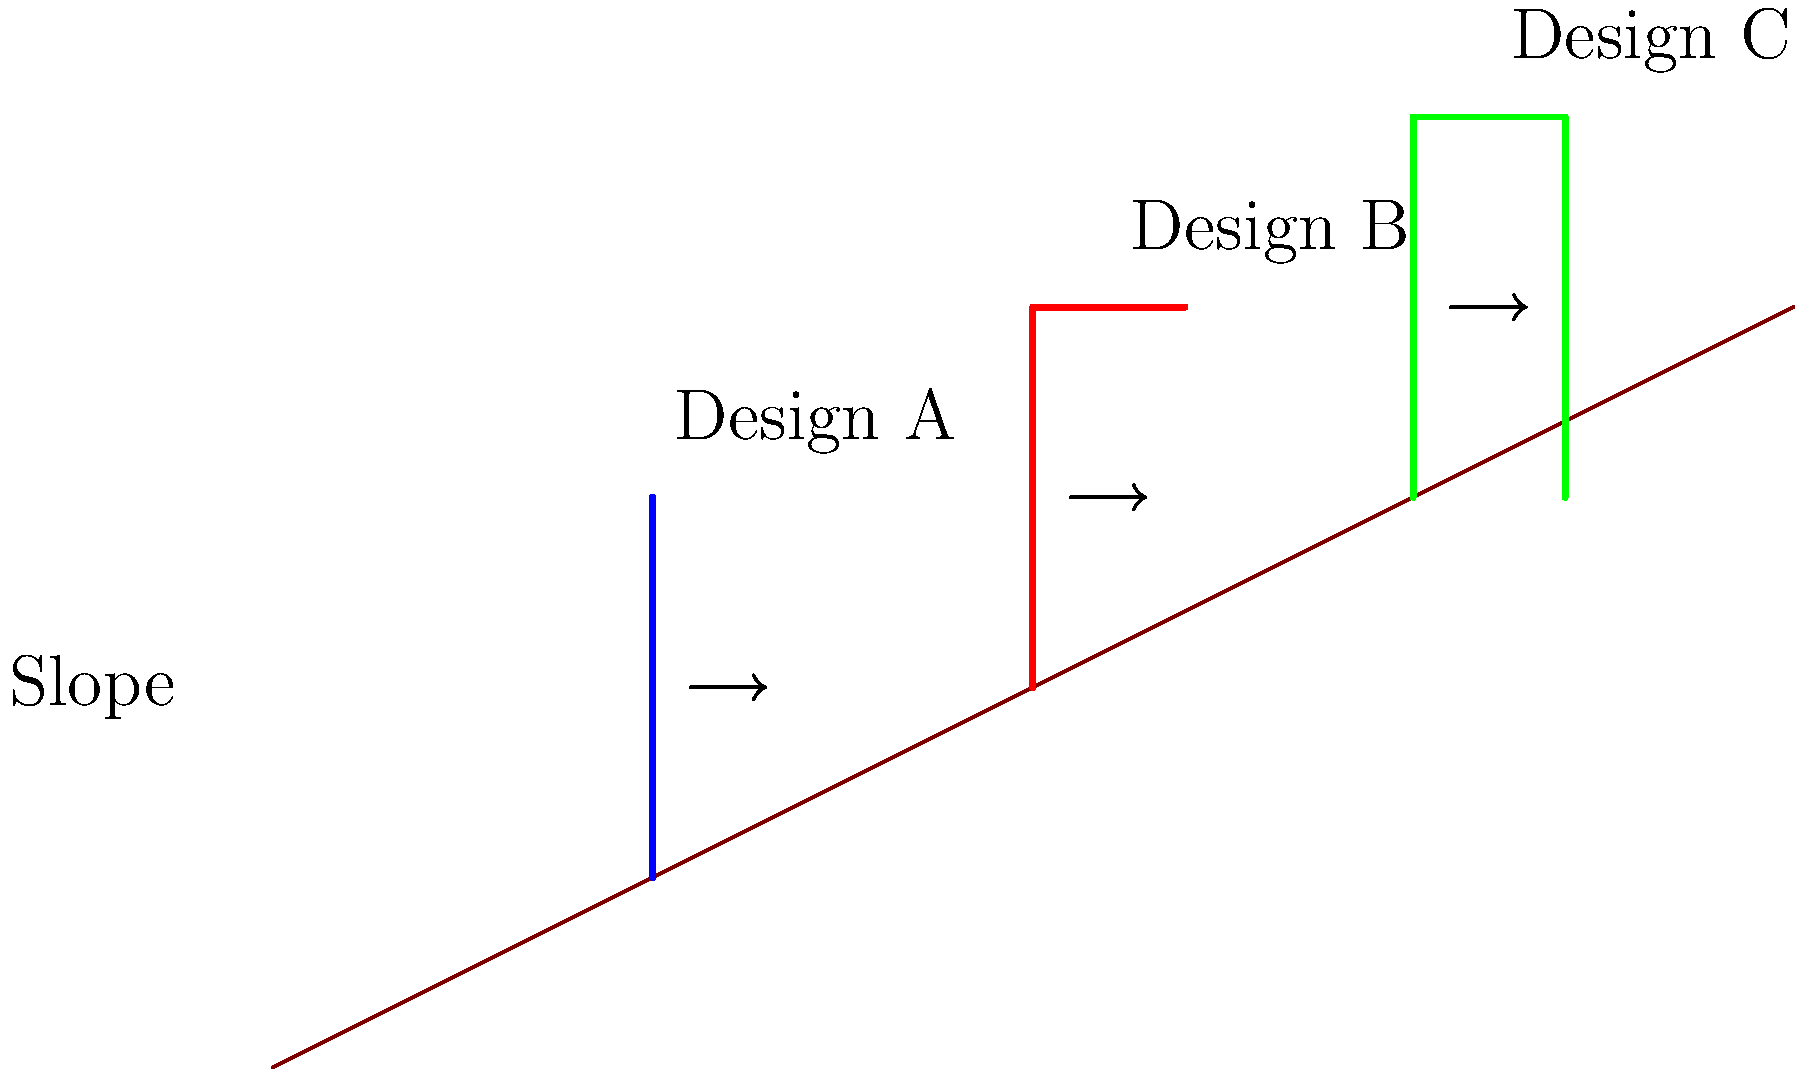As a local business owner in Tupelo, Mississippi, you're planning to build a storage facility on a sloped property. Three retaining wall designs (A, B, and C) have been proposed for the site. Based on the diagram, which design is likely to provide the best stability against lateral earth pressure and why? To analyze the stability of the retaining wall designs, we need to consider several factors:

1. Wall height: Taller walls experience greater lateral earth pressure.
2. Wall shape: More complex shapes can distribute forces better.
3. Counterforce: Elements that resist overturning moments.

Let's examine each design:

1. Design A: Simple vertical wall
   - Pros: Simplest to construct
   - Cons: No counterforce, vulnerable to overturning

2. Design B: L-shaped wall
   - Pros: Base extension provides some counterforce
   - Cons: Still relatively simple, moderate resistance to overturning

3. Design C: Inverted T-shaped wall
   - Pros: 
     a) Extended base in both directions provides significant counterforce
     b) Better distribution of soil pressure
     c) Increased resistance to sliding and overturning

   The extended base of Design C creates a larger soil mass above it, which adds to the wall's weight and stability. This design also has a better moment arm to resist overturning forces.

The lateral earth pressure ($P$) can be calculated using the equation:

$$P = \frac{1}{2} \gamma H^2 K_a$$

Where:
$\gamma$ = unit weight of soil
$H$ = height of wall
$K_a$ = active earth pressure coefficient

Design C's shape allows it to better resist this pressure through its improved geometry and weight distribution.
Answer: Design C (Inverted T-shape) provides the best stability due to its extended base and improved force distribution. 